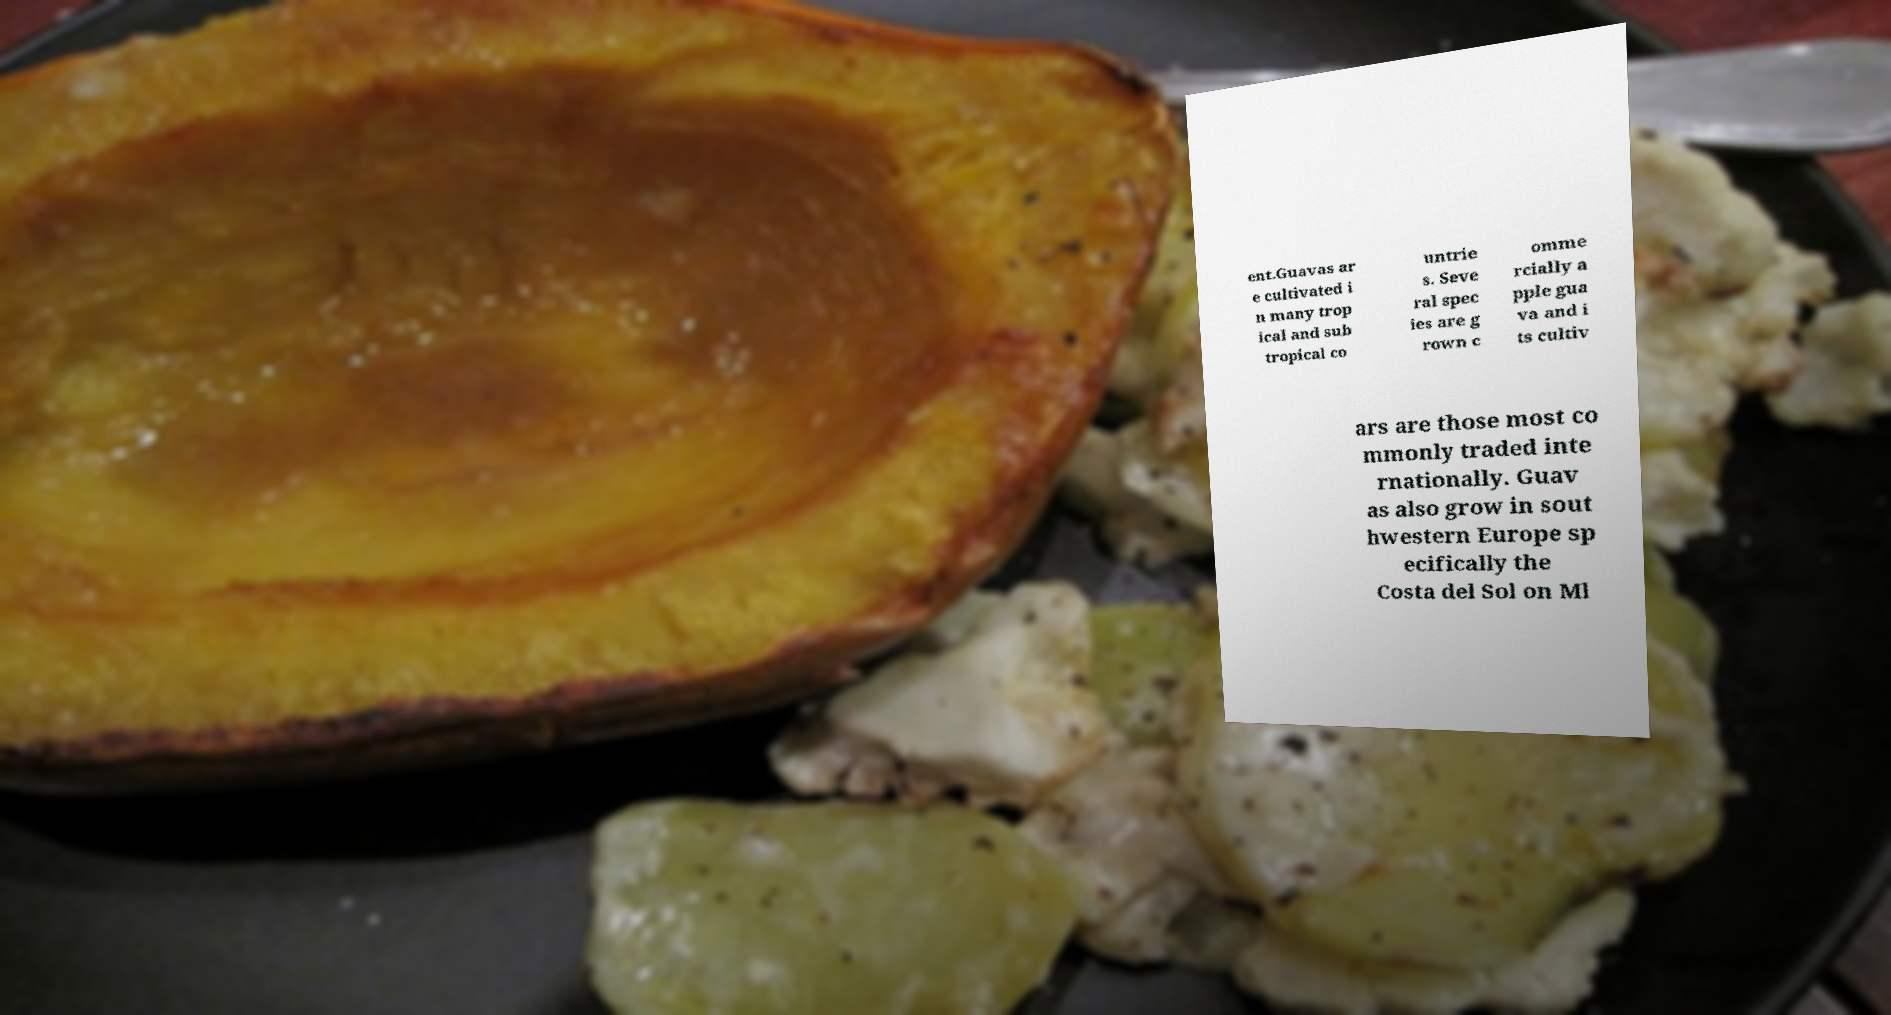What are the different varieties of guavas shown in the image? The image predominantly features a prepared dish that likely uses the common apple guava, known for its sweet, slightly floral flavor. This variety is favored in culinary applications, both for direct consumption and in recipes like the one shown, which appears to be a guava-based baked dish, possibly a guava tart or pie. 